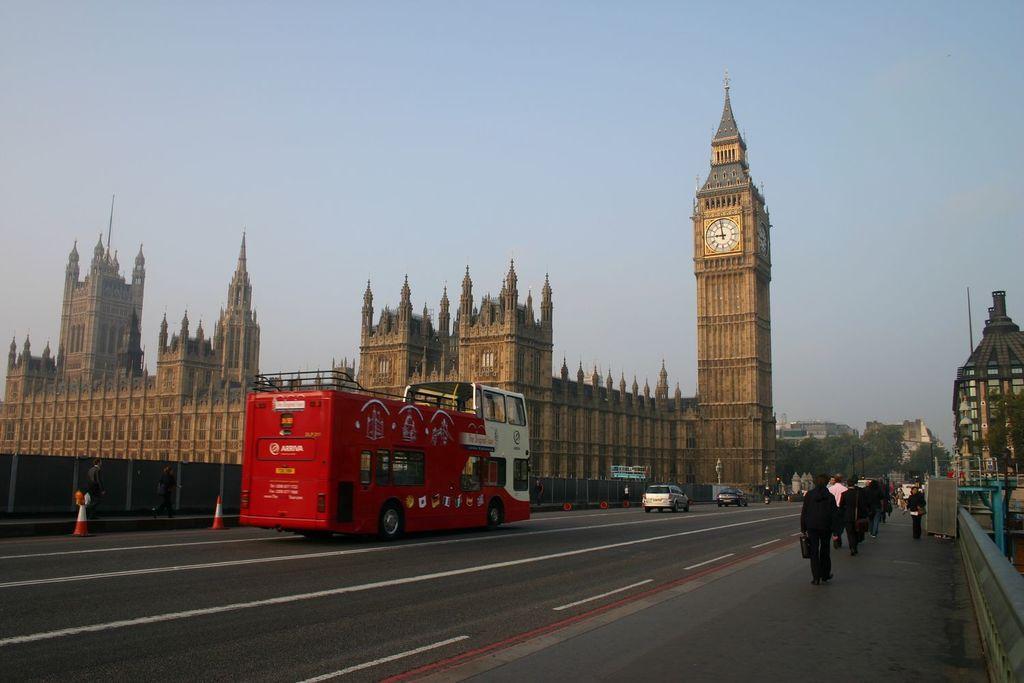In one or two sentences, can you explain what this image depicts? There is a road. On that there are many vehicles. On the right side there is a sidewalk. Many people are walking through the sidewalk. Also there is a building. Near to the road there are traffic cones. Also there is a building with tower. On the tower there are clocks. In the background there are trees, buildings and sky. 